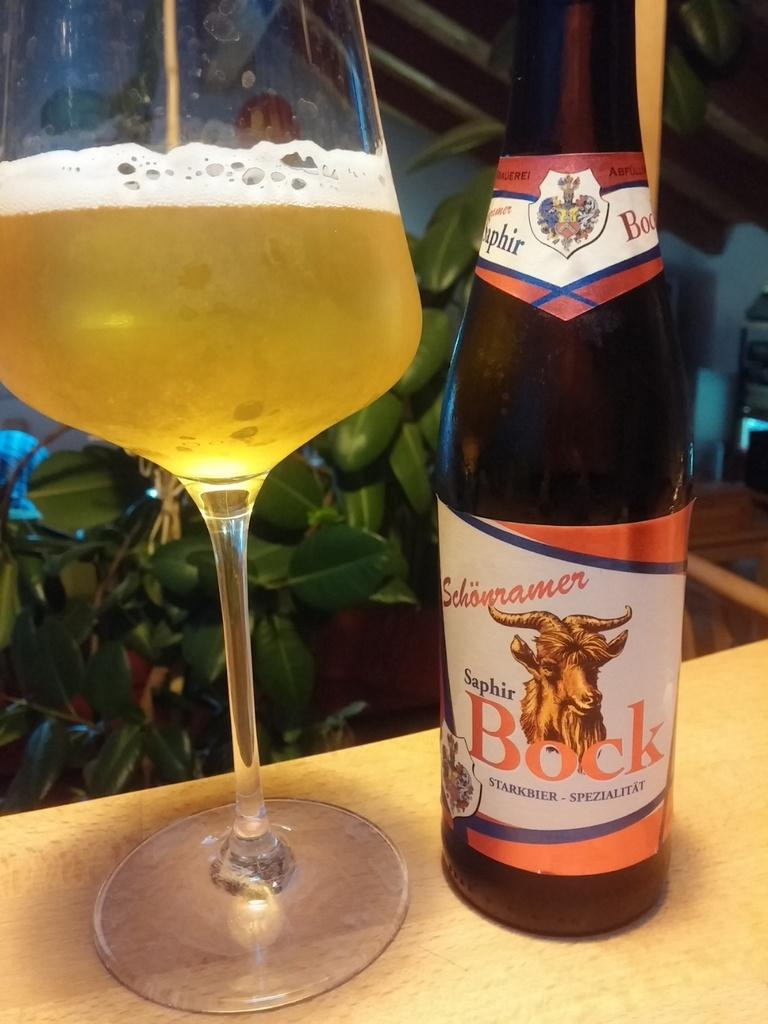<image>
Write a terse but informative summary of the picture. Beer bottle that says bock poured out into a glass 